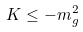<formula> <loc_0><loc_0><loc_500><loc_500>K \leq - m _ { g } ^ { 2 }</formula> 